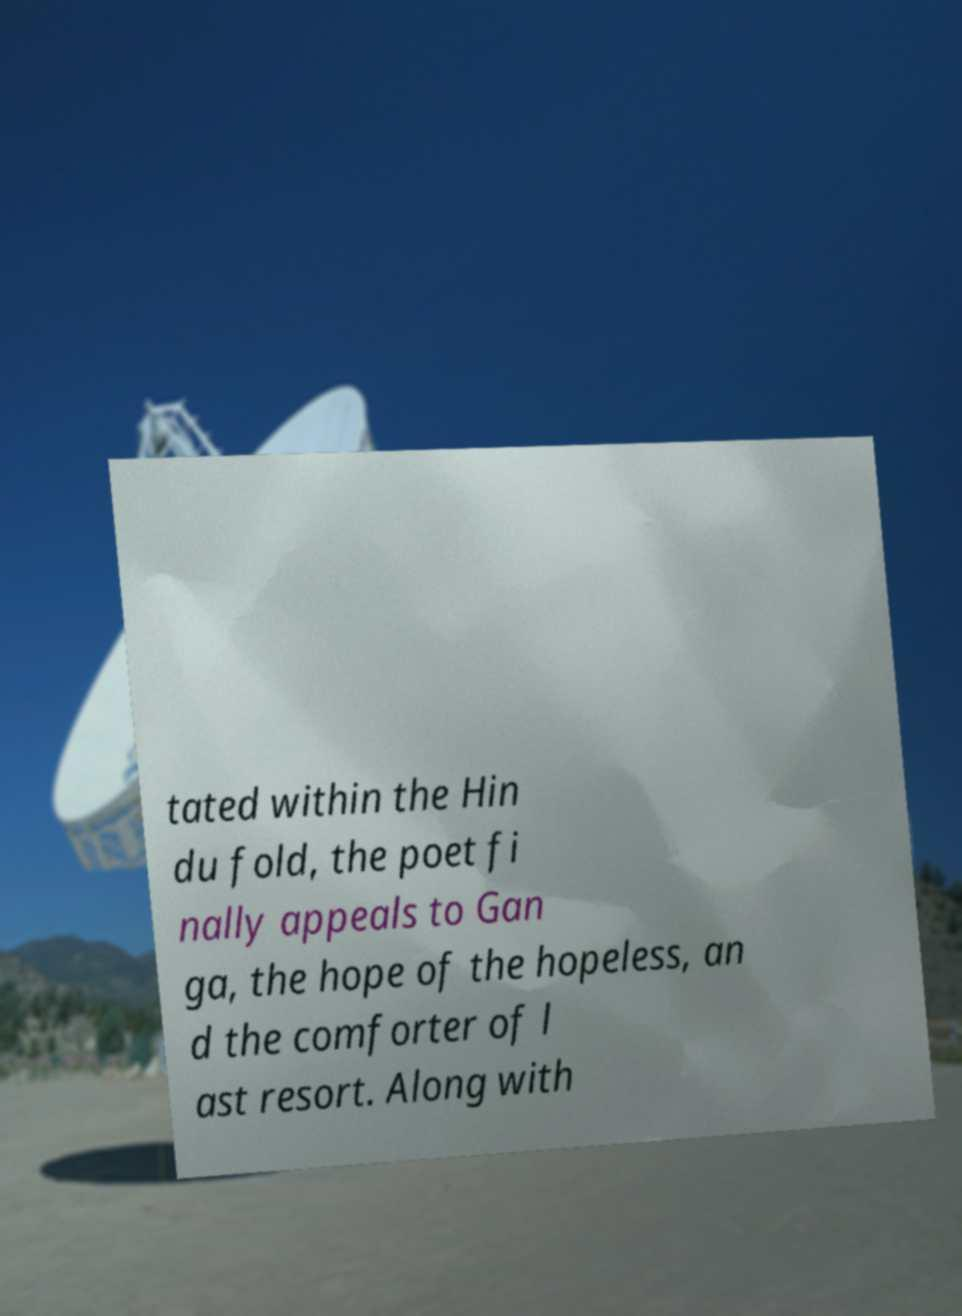Please read and relay the text visible in this image. What does it say? tated within the Hin du fold, the poet fi nally appeals to Gan ga, the hope of the hopeless, an d the comforter of l ast resort. Along with 